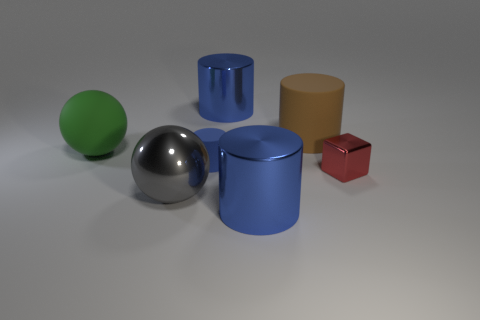Does the thing to the left of the gray object have the same shape as the gray object?
Offer a terse response. Yes. How many gray metallic things have the same size as the brown rubber thing?
Keep it short and to the point. 1. Are there any blue matte cylinders that are in front of the big blue cylinder in front of the small cube?
Provide a short and direct response. No. How many objects are cylinders that are in front of the small cylinder or small cyan matte objects?
Offer a very short reply. 1. How many tiny matte cylinders are there?
Ensure brevity in your answer.  1. What shape is the gray object that is made of the same material as the red thing?
Give a very brief answer. Sphere. How big is the sphere that is in front of the rubber cylinder on the left side of the big brown matte object?
Give a very brief answer. Large. What number of things are metal blocks that are in front of the small blue object or big objects that are on the left side of the tiny blue matte cylinder?
Provide a succinct answer. 3. Are there fewer brown cylinders than cyan matte spheres?
Your response must be concise. No. What number of objects are tiny blue objects or big rubber spheres?
Provide a succinct answer. 2. 